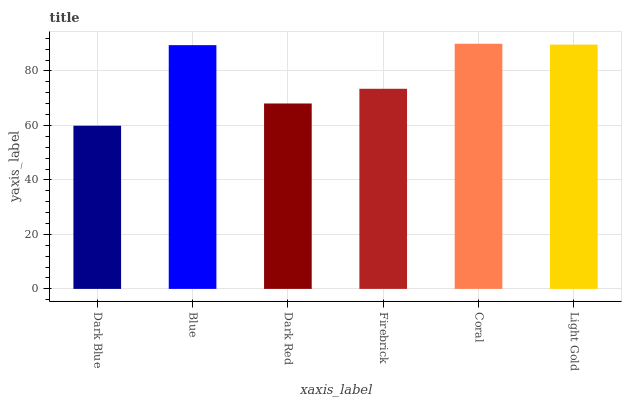Is Blue the minimum?
Answer yes or no. No. Is Blue the maximum?
Answer yes or no. No. Is Blue greater than Dark Blue?
Answer yes or no. Yes. Is Dark Blue less than Blue?
Answer yes or no. Yes. Is Dark Blue greater than Blue?
Answer yes or no. No. Is Blue less than Dark Blue?
Answer yes or no. No. Is Blue the high median?
Answer yes or no. Yes. Is Firebrick the low median?
Answer yes or no. Yes. Is Light Gold the high median?
Answer yes or no. No. Is Blue the low median?
Answer yes or no. No. 